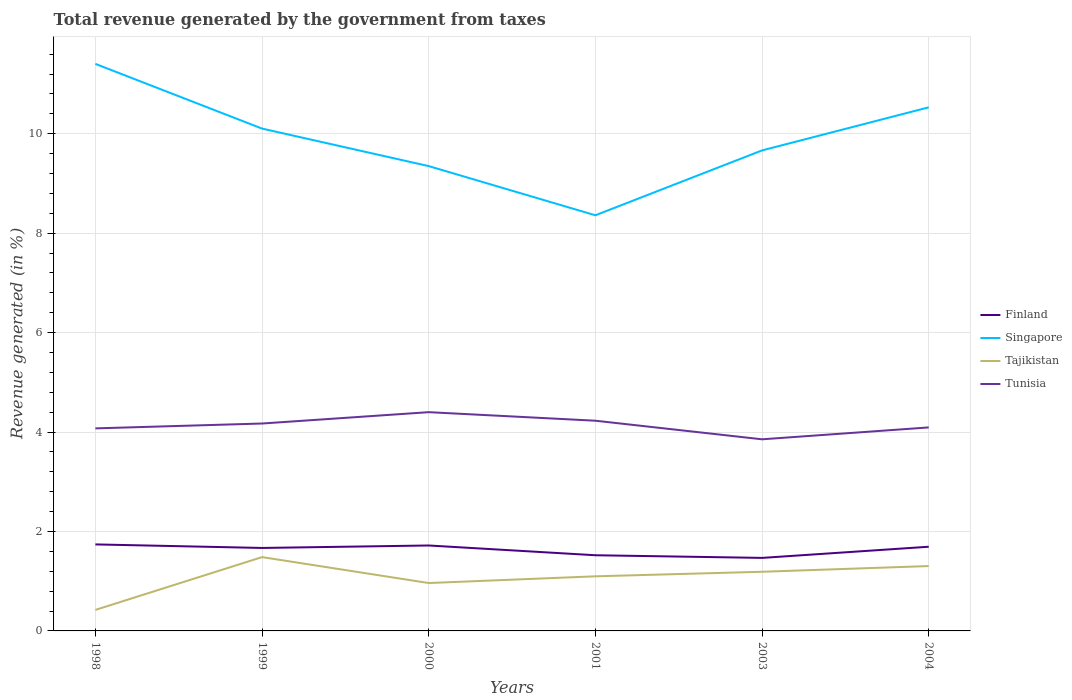How many different coloured lines are there?
Provide a short and direct response. 4. Is the number of lines equal to the number of legend labels?
Your response must be concise. Yes. Across all years, what is the maximum total revenue generated in Finland?
Make the answer very short. 1.47. What is the total total revenue generated in Tajikistan in the graph?
Keep it short and to the point. 0.18. What is the difference between the highest and the second highest total revenue generated in Tunisia?
Your response must be concise. 0.55. Is the total revenue generated in Finland strictly greater than the total revenue generated in Tunisia over the years?
Provide a succinct answer. Yes. How many lines are there?
Offer a terse response. 4. What is the difference between two consecutive major ticks on the Y-axis?
Ensure brevity in your answer.  2. Does the graph contain any zero values?
Keep it short and to the point. No. Does the graph contain grids?
Offer a very short reply. Yes. How many legend labels are there?
Give a very brief answer. 4. How are the legend labels stacked?
Your response must be concise. Vertical. What is the title of the graph?
Offer a terse response. Total revenue generated by the government from taxes. Does "Iran" appear as one of the legend labels in the graph?
Ensure brevity in your answer.  No. What is the label or title of the Y-axis?
Your answer should be compact. Revenue generated (in %). What is the Revenue generated (in %) in Finland in 1998?
Give a very brief answer. 1.74. What is the Revenue generated (in %) of Singapore in 1998?
Your answer should be compact. 11.41. What is the Revenue generated (in %) in Tajikistan in 1998?
Provide a short and direct response. 0.42. What is the Revenue generated (in %) in Tunisia in 1998?
Offer a very short reply. 4.07. What is the Revenue generated (in %) in Finland in 1999?
Make the answer very short. 1.67. What is the Revenue generated (in %) in Singapore in 1999?
Provide a succinct answer. 10.1. What is the Revenue generated (in %) of Tajikistan in 1999?
Your answer should be very brief. 1.48. What is the Revenue generated (in %) in Tunisia in 1999?
Your answer should be very brief. 4.17. What is the Revenue generated (in %) in Finland in 2000?
Offer a terse response. 1.72. What is the Revenue generated (in %) of Singapore in 2000?
Ensure brevity in your answer.  9.35. What is the Revenue generated (in %) in Tajikistan in 2000?
Your response must be concise. 0.96. What is the Revenue generated (in %) in Tunisia in 2000?
Your response must be concise. 4.4. What is the Revenue generated (in %) of Finland in 2001?
Your answer should be very brief. 1.52. What is the Revenue generated (in %) of Singapore in 2001?
Ensure brevity in your answer.  8.36. What is the Revenue generated (in %) in Tajikistan in 2001?
Your answer should be very brief. 1.1. What is the Revenue generated (in %) of Tunisia in 2001?
Offer a very short reply. 4.23. What is the Revenue generated (in %) of Finland in 2003?
Ensure brevity in your answer.  1.47. What is the Revenue generated (in %) in Singapore in 2003?
Provide a succinct answer. 9.67. What is the Revenue generated (in %) of Tajikistan in 2003?
Offer a terse response. 1.19. What is the Revenue generated (in %) of Tunisia in 2003?
Give a very brief answer. 3.85. What is the Revenue generated (in %) of Finland in 2004?
Provide a succinct answer. 1.69. What is the Revenue generated (in %) of Singapore in 2004?
Offer a terse response. 10.53. What is the Revenue generated (in %) in Tajikistan in 2004?
Your answer should be very brief. 1.3. What is the Revenue generated (in %) of Tunisia in 2004?
Your answer should be compact. 4.09. Across all years, what is the maximum Revenue generated (in %) of Finland?
Keep it short and to the point. 1.74. Across all years, what is the maximum Revenue generated (in %) in Singapore?
Make the answer very short. 11.41. Across all years, what is the maximum Revenue generated (in %) in Tajikistan?
Give a very brief answer. 1.48. Across all years, what is the maximum Revenue generated (in %) in Tunisia?
Your answer should be very brief. 4.4. Across all years, what is the minimum Revenue generated (in %) in Finland?
Offer a very short reply. 1.47. Across all years, what is the minimum Revenue generated (in %) of Singapore?
Your answer should be very brief. 8.36. Across all years, what is the minimum Revenue generated (in %) in Tajikistan?
Offer a terse response. 0.42. Across all years, what is the minimum Revenue generated (in %) of Tunisia?
Keep it short and to the point. 3.85. What is the total Revenue generated (in %) of Finland in the graph?
Your response must be concise. 9.81. What is the total Revenue generated (in %) of Singapore in the graph?
Offer a very short reply. 59.42. What is the total Revenue generated (in %) of Tajikistan in the graph?
Ensure brevity in your answer.  6.46. What is the total Revenue generated (in %) of Tunisia in the graph?
Your answer should be very brief. 24.82. What is the difference between the Revenue generated (in %) in Finland in 1998 and that in 1999?
Offer a very short reply. 0.07. What is the difference between the Revenue generated (in %) of Singapore in 1998 and that in 1999?
Offer a terse response. 1.3. What is the difference between the Revenue generated (in %) of Tajikistan in 1998 and that in 1999?
Provide a short and direct response. -1.06. What is the difference between the Revenue generated (in %) of Tunisia in 1998 and that in 1999?
Offer a terse response. -0.1. What is the difference between the Revenue generated (in %) in Finland in 1998 and that in 2000?
Give a very brief answer. 0.02. What is the difference between the Revenue generated (in %) in Singapore in 1998 and that in 2000?
Make the answer very short. 2.06. What is the difference between the Revenue generated (in %) in Tajikistan in 1998 and that in 2000?
Your response must be concise. -0.54. What is the difference between the Revenue generated (in %) in Tunisia in 1998 and that in 2000?
Offer a very short reply. -0.33. What is the difference between the Revenue generated (in %) in Finland in 1998 and that in 2001?
Your answer should be very brief. 0.22. What is the difference between the Revenue generated (in %) of Singapore in 1998 and that in 2001?
Provide a succinct answer. 3.05. What is the difference between the Revenue generated (in %) in Tajikistan in 1998 and that in 2001?
Provide a succinct answer. -0.68. What is the difference between the Revenue generated (in %) of Tunisia in 1998 and that in 2001?
Your answer should be very brief. -0.15. What is the difference between the Revenue generated (in %) in Finland in 1998 and that in 2003?
Offer a very short reply. 0.27. What is the difference between the Revenue generated (in %) of Singapore in 1998 and that in 2003?
Offer a terse response. 1.74. What is the difference between the Revenue generated (in %) in Tajikistan in 1998 and that in 2003?
Your response must be concise. -0.77. What is the difference between the Revenue generated (in %) in Tunisia in 1998 and that in 2003?
Keep it short and to the point. 0.22. What is the difference between the Revenue generated (in %) in Finland in 1998 and that in 2004?
Your response must be concise. 0.05. What is the difference between the Revenue generated (in %) of Singapore in 1998 and that in 2004?
Ensure brevity in your answer.  0.87. What is the difference between the Revenue generated (in %) of Tajikistan in 1998 and that in 2004?
Make the answer very short. -0.88. What is the difference between the Revenue generated (in %) in Tunisia in 1998 and that in 2004?
Offer a very short reply. -0.02. What is the difference between the Revenue generated (in %) in Finland in 1999 and that in 2000?
Your response must be concise. -0.05. What is the difference between the Revenue generated (in %) in Singapore in 1999 and that in 2000?
Offer a very short reply. 0.75. What is the difference between the Revenue generated (in %) of Tajikistan in 1999 and that in 2000?
Your answer should be very brief. 0.52. What is the difference between the Revenue generated (in %) of Tunisia in 1999 and that in 2000?
Give a very brief answer. -0.23. What is the difference between the Revenue generated (in %) in Finland in 1999 and that in 2001?
Make the answer very short. 0.15. What is the difference between the Revenue generated (in %) of Singapore in 1999 and that in 2001?
Your response must be concise. 1.74. What is the difference between the Revenue generated (in %) in Tajikistan in 1999 and that in 2001?
Provide a succinct answer. 0.39. What is the difference between the Revenue generated (in %) in Tunisia in 1999 and that in 2001?
Make the answer very short. -0.06. What is the difference between the Revenue generated (in %) in Finland in 1999 and that in 2003?
Provide a short and direct response. 0.2. What is the difference between the Revenue generated (in %) in Singapore in 1999 and that in 2003?
Offer a very short reply. 0.44. What is the difference between the Revenue generated (in %) of Tajikistan in 1999 and that in 2003?
Your answer should be compact. 0.29. What is the difference between the Revenue generated (in %) of Tunisia in 1999 and that in 2003?
Your response must be concise. 0.32. What is the difference between the Revenue generated (in %) in Finland in 1999 and that in 2004?
Make the answer very short. -0.02. What is the difference between the Revenue generated (in %) of Singapore in 1999 and that in 2004?
Provide a short and direct response. -0.43. What is the difference between the Revenue generated (in %) in Tajikistan in 1999 and that in 2004?
Keep it short and to the point. 0.18. What is the difference between the Revenue generated (in %) of Tunisia in 1999 and that in 2004?
Give a very brief answer. 0.08. What is the difference between the Revenue generated (in %) in Finland in 2000 and that in 2001?
Keep it short and to the point. 0.2. What is the difference between the Revenue generated (in %) of Tajikistan in 2000 and that in 2001?
Offer a very short reply. -0.14. What is the difference between the Revenue generated (in %) in Tunisia in 2000 and that in 2001?
Keep it short and to the point. 0.17. What is the difference between the Revenue generated (in %) of Finland in 2000 and that in 2003?
Provide a short and direct response. 0.25. What is the difference between the Revenue generated (in %) of Singapore in 2000 and that in 2003?
Keep it short and to the point. -0.32. What is the difference between the Revenue generated (in %) of Tajikistan in 2000 and that in 2003?
Ensure brevity in your answer.  -0.23. What is the difference between the Revenue generated (in %) in Tunisia in 2000 and that in 2003?
Give a very brief answer. 0.55. What is the difference between the Revenue generated (in %) of Finland in 2000 and that in 2004?
Your answer should be compact. 0.03. What is the difference between the Revenue generated (in %) of Singapore in 2000 and that in 2004?
Provide a succinct answer. -1.18. What is the difference between the Revenue generated (in %) in Tajikistan in 2000 and that in 2004?
Your answer should be compact. -0.34. What is the difference between the Revenue generated (in %) in Tunisia in 2000 and that in 2004?
Make the answer very short. 0.31. What is the difference between the Revenue generated (in %) of Finland in 2001 and that in 2003?
Keep it short and to the point. 0.05. What is the difference between the Revenue generated (in %) in Singapore in 2001 and that in 2003?
Ensure brevity in your answer.  -1.3. What is the difference between the Revenue generated (in %) in Tajikistan in 2001 and that in 2003?
Your answer should be very brief. -0.09. What is the difference between the Revenue generated (in %) in Tunisia in 2001 and that in 2003?
Ensure brevity in your answer.  0.37. What is the difference between the Revenue generated (in %) in Finland in 2001 and that in 2004?
Your answer should be very brief. -0.17. What is the difference between the Revenue generated (in %) in Singapore in 2001 and that in 2004?
Offer a terse response. -2.17. What is the difference between the Revenue generated (in %) of Tajikistan in 2001 and that in 2004?
Ensure brevity in your answer.  -0.21. What is the difference between the Revenue generated (in %) in Tunisia in 2001 and that in 2004?
Ensure brevity in your answer.  0.13. What is the difference between the Revenue generated (in %) of Finland in 2003 and that in 2004?
Offer a very short reply. -0.22. What is the difference between the Revenue generated (in %) of Singapore in 2003 and that in 2004?
Your answer should be very brief. -0.87. What is the difference between the Revenue generated (in %) of Tajikistan in 2003 and that in 2004?
Provide a succinct answer. -0.12. What is the difference between the Revenue generated (in %) in Tunisia in 2003 and that in 2004?
Ensure brevity in your answer.  -0.24. What is the difference between the Revenue generated (in %) in Finland in 1998 and the Revenue generated (in %) in Singapore in 1999?
Offer a very short reply. -8.36. What is the difference between the Revenue generated (in %) in Finland in 1998 and the Revenue generated (in %) in Tajikistan in 1999?
Your answer should be compact. 0.26. What is the difference between the Revenue generated (in %) in Finland in 1998 and the Revenue generated (in %) in Tunisia in 1999?
Your answer should be compact. -2.43. What is the difference between the Revenue generated (in %) in Singapore in 1998 and the Revenue generated (in %) in Tajikistan in 1999?
Make the answer very short. 9.92. What is the difference between the Revenue generated (in %) in Singapore in 1998 and the Revenue generated (in %) in Tunisia in 1999?
Your response must be concise. 7.23. What is the difference between the Revenue generated (in %) of Tajikistan in 1998 and the Revenue generated (in %) of Tunisia in 1999?
Offer a terse response. -3.75. What is the difference between the Revenue generated (in %) of Finland in 1998 and the Revenue generated (in %) of Singapore in 2000?
Your answer should be compact. -7.61. What is the difference between the Revenue generated (in %) of Finland in 1998 and the Revenue generated (in %) of Tajikistan in 2000?
Give a very brief answer. 0.78. What is the difference between the Revenue generated (in %) in Finland in 1998 and the Revenue generated (in %) in Tunisia in 2000?
Offer a very short reply. -2.66. What is the difference between the Revenue generated (in %) in Singapore in 1998 and the Revenue generated (in %) in Tajikistan in 2000?
Provide a short and direct response. 10.44. What is the difference between the Revenue generated (in %) of Singapore in 1998 and the Revenue generated (in %) of Tunisia in 2000?
Offer a very short reply. 7.01. What is the difference between the Revenue generated (in %) of Tajikistan in 1998 and the Revenue generated (in %) of Tunisia in 2000?
Offer a terse response. -3.98. What is the difference between the Revenue generated (in %) in Finland in 1998 and the Revenue generated (in %) in Singapore in 2001?
Keep it short and to the point. -6.62. What is the difference between the Revenue generated (in %) in Finland in 1998 and the Revenue generated (in %) in Tajikistan in 2001?
Offer a very short reply. 0.64. What is the difference between the Revenue generated (in %) of Finland in 1998 and the Revenue generated (in %) of Tunisia in 2001?
Offer a very short reply. -2.49. What is the difference between the Revenue generated (in %) of Singapore in 1998 and the Revenue generated (in %) of Tajikistan in 2001?
Offer a terse response. 10.31. What is the difference between the Revenue generated (in %) in Singapore in 1998 and the Revenue generated (in %) in Tunisia in 2001?
Your answer should be compact. 7.18. What is the difference between the Revenue generated (in %) of Tajikistan in 1998 and the Revenue generated (in %) of Tunisia in 2001?
Your answer should be compact. -3.81. What is the difference between the Revenue generated (in %) of Finland in 1998 and the Revenue generated (in %) of Singapore in 2003?
Offer a very short reply. -7.93. What is the difference between the Revenue generated (in %) of Finland in 1998 and the Revenue generated (in %) of Tajikistan in 2003?
Offer a very short reply. 0.55. What is the difference between the Revenue generated (in %) of Finland in 1998 and the Revenue generated (in %) of Tunisia in 2003?
Keep it short and to the point. -2.11. What is the difference between the Revenue generated (in %) of Singapore in 1998 and the Revenue generated (in %) of Tajikistan in 2003?
Your answer should be compact. 10.22. What is the difference between the Revenue generated (in %) in Singapore in 1998 and the Revenue generated (in %) in Tunisia in 2003?
Keep it short and to the point. 7.55. What is the difference between the Revenue generated (in %) of Tajikistan in 1998 and the Revenue generated (in %) of Tunisia in 2003?
Keep it short and to the point. -3.43. What is the difference between the Revenue generated (in %) of Finland in 1998 and the Revenue generated (in %) of Singapore in 2004?
Your answer should be compact. -8.79. What is the difference between the Revenue generated (in %) of Finland in 1998 and the Revenue generated (in %) of Tajikistan in 2004?
Make the answer very short. 0.44. What is the difference between the Revenue generated (in %) of Finland in 1998 and the Revenue generated (in %) of Tunisia in 2004?
Provide a short and direct response. -2.35. What is the difference between the Revenue generated (in %) of Singapore in 1998 and the Revenue generated (in %) of Tajikistan in 2004?
Make the answer very short. 10.1. What is the difference between the Revenue generated (in %) in Singapore in 1998 and the Revenue generated (in %) in Tunisia in 2004?
Your response must be concise. 7.31. What is the difference between the Revenue generated (in %) in Tajikistan in 1998 and the Revenue generated (in %) in Tunisia in 2004?
Make the answer very short. -3.67. What is the difference between the Revenue generated (in %) in Finland in 1999 and the Revenue generated (in %) in Singapore in 2000?
Offer a very short reply. -7.68. What is the difference between the Revenue generated (in %) in Finland in 1999 and the Revenue generated (in %) in Tajikistan in 2000?
Make the answer very short. 0.71. What is the difference between the Revenue generated (in %) of Finland in 1999 and the Revenue generated (in %) of Tunisia in 2000?
Offer a terse response. -2.73. What is the difference between the Revenue generated (in %) of Singapore in 1999 and the Revenue generated (in %) of Tajikistan in 2000?
Offer a terse response. 9.14. What is the difference between the Revenue generated (in %) in Singapore in 1999 and the Revenue generated (in %) in Tunisia in 2000?
Make the answer very short. 5.7. What is the difference between the Revenue generated (in %) in Tajikistan in 1999 and the Revenue generated (in %) in Tunisia in 2000?
Make the answer very short. -2.92. What is the difference between the Revenue generated (in %) of Finland in 1999 and the Revenue generated (in %) of Singapore in 2001?
Make the answer very short. -6.69. What is the difference between the Revenue generated (in %) in Finland in 1999 and the Revenue generated (in %) in Tajikistan in 2001?
Your response must be concise. 0.57. What is the difference between the Revenue generated (in %) of Finland in 1999 and the Revenue generated (in %) of Tunisia in 2001?
Provide a short and direct response. -2.56. What is the difference between the Revenue generated (in %) of Singapore in 1999 and the Revenue generated (in %) of Tajikistan in 2001?
Offer a terse response. 9.01. What is the difference between the Revenue generated (in %) in Singapore in 1999 and the Revenue generated (in %) in Tunisia in 2001?
Give a very brief answer. 5.88. What is the difference between the Revenue generated (in %) of Tajikistan in 1999 and the Revenue generated (in %) of Tunisia in 2001?
Your answer should be compact. -2.74. What is the difference between the Revenue generated (in %) in Finland in 1999 and the Revenue generated (in %) in Singapore in 2003?
Provide a short and direct response. -8. What is the difference between the Revenue generated (in %) in Finland in 1999 and the Revenue generated (in %) in Tajikistan in 2003?
Ensure brevity in your answer.  0.48. What is the difference between the Revenue generated (in %) of Finland in 1999 and the Revenue generated (in %) of Tunisia in 2003?
Give a very brief answer. -2.19. What is the difference between the Revenue generated (in %) in Singapore in 1999 and the Revenue generated (in %) in Tajikistan in 2003?
Ensure brevity in your answer.  8.91. What is the difference between the Revenue generated (in %) of Singapore in 1999 and the Revenue generated (in %) of Tunisia in 2003?
Give a very brief answer. 6.25. What is the difference between the Revenue generated (in %) in Tajikistan in 1999 and the Revenue generated (in %) in Tunisia in 2003?
Make the answer very short. -2.37. What is the difference between the Revenue generated (in %) of Finland in 1999 and the Revenue generated (in %) of Singapore in 2004?
Your answer should be compact. -8.86. What is the difference between the Revenue generated (in %) of Finland in 1999 and the Revenue generated (in %) of Tajikistan in 2004?
Your response must be concise. 0.36. What is the difference between the Revenue generated (in %) of Finland in 1999 and the Revenue generated (in %) of Tunisia in 2004?
Keep it short and to the point. -2.42. What is the difference between the Revenue generated (in %) in Singapore in 1999 and the Revenue generated (in %) in Tajikistan in 2004?
Your response must be concise. 8.8. What is the difference between the Revenue generated (in %) of Singapore in 1999 and the Revenue generated (in %) of Tunisia in 2004?
Offer a very short reply. 6.01. What is the difference between the Revenue generated (in %) of Tajikistan in 1999 and the Revenue generated (in %) of Tunisia in 2004?
Provide a short and direct response. -2.61. What is the difference between the Revenue generated (in %) of Finland in 2000 and the Revenue generated (in %) of Singapore in 2001?
Provide a succinct answer. -6.64. What is the difference between the Revenue generated (in %) in Finland in 2000 and the Revenue generated (in %) in Tajikistan in 2001?
Make the answer very short. 0.62. What is the difference between the Revenue generated (in %) of Finland in 2000 and the Revenue generated (in %) of Tunisia in 2001?
Keep it short and to the point. -2.51. What is the difference between the Revenue generated (in %) in Singapore in 2000 and the Revenue generated (in %) in Tajikistan in 2001?
Give a very brief answer. 8.25. What is the difference between the Revenue generated (in %) in Singapore in 2000 and the Revenue generated (in %) in Tunisia in 2001?
Give a very brief answer. 5.12. What is the difference between the Revenue generated (in %) of Tajikistan in 2000 and the Revenue generated (in %) of Tunisia in 2001?
Provide a succinct answer. -3.26. What is the difference between the Revenue generated (in %) in Finland in 2000 and the Revenue generated (in %) in Singapore in 2003?
Offer a terse response. -7.95. What is the difference between the Revenue generated (in %) in Finland in 2000 and the Revenue generated (in %) in Tajikistan in 2003?
Provide a short and direct response. 0.53. What is the difference between the Revenue generated (in %) of Finland in 2000 and the Revenue generated (in %) of Tunisia in 2003?
Make the answer very short. -2.14. What is the difference between the Revenue generated (in %) in Singapore in 2000 and the Revenue generated (in %) in Tajikistan in 2003?
Your answer should be compact. 8.16. What is the difference between the Revenue generated (in %) in Singapore in 2000 and the Revenue generated (in %) in Tunisia in 2003?
Your answer should be compact. 5.5. What is the difference between the Revenue generated (in %) of Tajikistan in 2000 and the Revenue generated (in %) of Tunisia in 2003?
Ensure brevity in your answer.  -2.89. What is the difference between the Revenue generated (in %) in Finland in 2000 and the Revenue generated (in %) in Singapore in 2004?
Your answer should be compact. -8.81. What is the difference between the Revenue generated (in %) of Finland in 2000 and the Revenue generated (in %) of Tajikistan in 2004?
Provide a succinct answer. 0.41. What is the difference between the Revenue generated (in %) of Finland in 2000 and the Revenue generated (in %) of Tunisia in 2004?
Give a very brief answer. -2.37. What is the difference between the Revenue generated (in %) in Singapore in 2000 and the Revenue generated (in %) in Tajikistan in 2004?
Offer a very short reply. 8.04. What is the difference between the Revenue generated (in %) of Singapore in 2000 and the Revenue generated (in %) of Tunisia in 2004?
Keep it short and to the point. 5.26. What is the difference between the Revenue generated (in %) in Tajikistan in 2000 and the Revenue generated (in %) in Tunisia in 2004?
Give a very brief answer. -3.13. What is the difference between the Revenue generated (in %) in Finland in 2001 and the Revenue generated (in %) in Singapore in 2003?
Give a very brief answer. -8.14. What is the difference between the Revenue generated (in %) in Finland in 2001 and the Revenue generated (in %) in Tajikistan in 2003?
Your response must be concise. 0.33. What is the difference between the Revenue generated (in %) of Finland in 2001 and the Revenue generated (in %) of Tunisia in 2003?
Your response must be concise. -2.33. What is the difference between the Revenue generated (in %) of Singapore in 2001 and the Revenue generated (in %) of Tajikistan in 2003?
Offer a very short reply. 7.17. What is the difference between the Revenue generated (in %) of Singapore in 2001 and the Revenue generated (in %) of Tunisia in 2003?
Give a very brief answer. 4.51. What is the difference between the Revenue generated (in %) in Tajikistan in 2001 and the Revenue generated (in %) in Tunisia in 2003?
Give a very brief answer. -2.76. What is the difference between the Revenue generated (in %) of Finland in 2001 and the Revenue generated (in %) of Singapore in 2004?
Keep it short and to the point. -9.01. What is the difference between the Revenue generated (in %) in Finland in 2001 and the Revenue generated (in %) in Tajikistan in 2004?
Your answer should be very brief. 0.22. What is the difference between the Revenue generated (in %) in Finland in 2001 and the Revenue generated (in %) in Tunisia in 2004?
Provide a succinct answer. -2.57. What is the difference between the Revenue generated (in %) in Singapore in 2001 and the Revenue generated (in %) in Tajikistan in 2004?
Your answer should be very brief. 7.06. What is the difference between the Revenue generated (in %) of Singapore in 2001 and the Revenue generated (in %) of Tunisia in 2004?
Your answer should be compact. 4.27. What is the difference between the Revenue generated (in %) of Tajikistan in 2001 and the Revenue generated (in %) of Tunisia in 2004?
Provide a short and direct response. -2.99. What is the difference between the Revenue generated (in %) in Finland in 2003 and the Revenue generated (in %) in Singapore in 2004?
Your answer should be very brief. -9.06. What is the difference between the Revenue generated (in %) of Finland in 2003 and the Revenue generated (in %) of Tajikistan in 2004?
Your answer should be compact. 0.16. What is the difference between the Revenue generated (in %) of Finland in 2003 and the Revenue generated (in %) of Tunisia in 2004?
Make the answer very short. -2.62. What is the difference between the Revenue generated (in %) of Singapore in 2003 and the Revenue generated (in %) of Tajikistan in 2004?
Keep it short and to the point. 8.36. What is the difference between the Revenue generated (in %) in Singapore in 2003 and the Revenue generated (in %) in Tunisia in 2004?
Provide a short and direct response. 5.57. What is the difference between the Revenue generated (in %) of Tajikistan in 2003 and the Revenue generated (in %) of Tunisia in 2004?
Your answer should be compact. -2.9. What is the average Revenue generated (in %) of Finland per year?
Offer a terse response. 1.64. What is the average Revenue generated (in %) of Singapore per year?
Provide a short and direct response. 9.9. What is the average Revenue generated (in %) of Tajikistan per year?
Give a very brief answer. 1.08. What is the average Revenue generated (in %) in Tunisia per year?
Make the answer very short. 4.14. In the year 1998, what is the difference between the Revenue generated (in %) of Finland and Revenue generated (in %) of Singapore?
Ensure brevity in your answer.  -9.67. In the year 1998, what is the difference between the Revenue generated (in %) in Finland and Revenue generated (in %) in Tajikistan?
Provide a succinct answer. 1.32. In the year 1998, what is the difference between the Revenue generated (in %) of Finland and Revenue generated (in %) of Tunisia?
Ensure brevity in your answer.  -2.33. In the year 1998, what is the difference between the Revenue generated (in %) in Singapore and Revenue generated (in %) in Tajikistan?
Offer a terse response. 10.98. In the year 1998, what is the difference between the Revenue generated (in %) in Singapore and Revenue generated (in %) in Tunisia?
Keep it short and to the point. 7.33. In the year 1998, what is the difference between the Revenue generated (in %) in Tajikistan and Revenue generated (in %) in Tunisia?
Provide a short and direct response. -3.65. In the year 1999, what is the difference between the Revenue generated (in %) of Finland and Revenue generated (in %) of Singapore?
Offer a terse response. -8.44. In the year 1999, what is the difference between the Revenue generated (in %) in Finland and Revenue generated (in %) in Tajikistan?
Your answer should be very brief. 0.18. In the year 1999, what is the difference between the Revenue generated (in %) in Finland and Revenue generated (in %) in Tunisia?
Your answer should be compact. -2.5. In the year 1999, what is the difference between the Revenue generated (in %) in Singapore and Revenue generated (in %) in Tajikistan?
Provide a short and direct response. 8.62. In the year 1999, what is the difference between the Revenue generated (in %) in Singapore and Revenue generated (in %) in Tunisia?
Give a very brief answer. 5.93. In the year 1999, what is the difference between the Revenue generated (in %) of Tajikistan and Revenue generated (in %) of Tunisia?
Provide a succinct answer. -2.69. In the year 2000, what is the difference between the Revenue generated (in %) in Finland and Revenue generated (in %) in Singapore?
Your answer should be very brief. -7.63. In the year 2000, what is the difference between the Revenue generated (in %) of Finland and Revenue generated (in %) of Tajikistan?
Ensure brevity in your answer.  0.76. In the year 2000, what is the difference between the Revenue generated (in %) of Finland and Revenue generated (in %) of Tunisia?
Ensure brevity in your answer.  -2.68. In the year 2000, what is the difference between the Revenue generated (in %) in Singapore and Revenue generated (in %) in Tajikistan?
Your answer should be compact. 8.39. In the year 2000, what is the difference between the Revenue generated (in %) of Singapore and Revenue generated (in %) of Tunisia?
Provide a short and direct response. 4.95. In the year 2000, what is the difference between the Revenue generated (in %) in Tajikistan and Revenue generated (in %) in Tunisia?
Give a very brief answer. -3.44. In the year 2001, what is the difference between the Revenue generated (in %) in Finland and Revenue generated (in %) in Singapore?
Provide a succinct answer. -6.84. In the year 2001, what is the difference between the Revenue generated (in %) of Finland and Revenue generated (in %) of Tajikistan?
Give a very brief answer. 0.42. In the year 2001, what is the difference between the Revenue generated (in %) of Finland and Revenue generated (in %) of Tunisia?
Your answer should be very brief. -2.71. In the year 2001, what is the difference between the Revenue generated (in %) in Singapore and Revenue generated (in %) in Tajikistan?
Make the answer very short. 7.26. In the year 2001, what is the difference between the Revenue generated (in %) in Singapore and Revenue generated (in %) in Tunisia?
Keep it short and to the point. 4.13. In the year 2001, what is the difference between the Revenue generated (in %) in Tajikistan and Revenue generated (in %) in Tunisia?
Give a very brief answer. -3.13. In the year 2003, what is the difference between the Revenue generated (in %) of Finland and Revenue generated (in %) of Singapore?
Provide a short and direct response. -8.2. In the year 2003, what is the difference between the Revenue generated (in %) of Finland and Revenue generated (in %) of Tajikistan?
Give a very brief answer. 0.28. In the year 2003, what is the difference between the Revenue generated (in %) in Finland and Revenue generated (in %) in Tunisia?
Provide a short and direct response. -2.39. In the year 2003, what is the difference between the Revenue generated (in %) of Singapore and Revenue generated (in %) of Tajikistan?
Your answer should be very brief. 8.48. In the year 2003, what is the difference between the Revenue generated (in %) of Singapore and Revenue generated (in %) of Tunisia?
Give a very brief answer. 5.81. In the year 2003, what is the difference between the Revenue generated (in %) in Tajikistan and Revenue generated (in %) in Tunisia?
Provide a succinct answer. -2.66. In the year 2004, what is the difference between the Revenue generated (in %) of Finland and Revenue generated (in %) of Singapore?
Provide a short and direct response. -8.84. In the year 2004, what is the difference between the Revenue generated (in %) of Finland and Revenue generated (in %) of Tajikistan?
Your answer should be very brief. 0.39. In the year 2004, what is the difference between the Revenue generated (in %) in Singapore and Revenue generated (in %) in Tajikistan?
Provide a short and direct response. 9.23. In the year 2004, what is the difference between the Revenue generated (in %) of Singapore and Revenue generated (in %) of Tunisia?
Your response must be concise. 6.44. In the year 2004, what is the difference between the Revenue generated (in %) in Tajikistan and Revenue generated (in %) in Tunisia?
Your response must be concise. -2.79. What is the ratio of the Revenue generated (in %) of Finland in 1998 to that in 1999?
Offer a terse response. 1.04. What is the ratio of the Revenue generated (in %) in Singapore in 1998 to that in 1999?
Your answer should be compact. 1.13. What is the ratio of the Revenue generated (in %) of Tajikistan in 1998 to that in 1999?
Your answer should be compact. 0.28. What is the ratio of the Revenue generated (in %) in Tunisia in 1998 to that in 1999?
Your response must be concise. 0.98. What is the ratio of the Revenue generated (in %) in Finland in 1998 to that in 2000?
Offer a terse response. 1.01. What is the ratio of the Revenue generated (in %) of Singapore in 1998 to that in 2000?
Provide a succinct answer. 1.22. What is the ratio of the Revenue generated (in %) of Tajikistan in 1998 to that in 2000?
Your answer should be very brief. 0.44. What is the ratio of the Revenue generated (in %) of Tunisia in 1998 to that in 2000?
Offer a terse response. 0.93. What is the ratio of the Revenue generated (in %) of Finland in 1998 to that in 2001?
Ensure brevity in your answer.  1.14. What is the ratio of the Revenue generated (in %) of Singapore in 1998 to that in 2001?
Keep it short and to the point. 1.36. What is the ratio of the Revenue generated (in %) in Tajikistan in 1998 to that in 2001?
Ensure brevity in your answer.  0.38. What is the ratio of the Revenue generated (in %) in Tunisia in 1998 to that in 2001?
Offer a very short reply. 0.96. What is the ratio of the Revenue generated (in %) in Finland in 1998 to that in 2003?
Your answer should be compact. 1.18. What is the ratio of the Revenue generated (in %) in Singapore in 1998 to that in 2003?
Provide a short and direct response. 1.18. What is the ratio of the Revenue generated (in %) in Tajikistan in 1998 to that in 2003?
Offer a terse response. 0.36. What is the ratio of the Revenue generated (in %) in Tunisia in 1998 to that in 2003?
Your answer should be very brief. 1.06. What is the ratio of the Revenue generated (in %) in Finland in 1998 to that in 2004?
Keep it short and to the point. 1.03. What is the ratio of the Revenue generated (in %) of Singapore in 1998 to that in 2004?
Your answer should be very brief. 1.08. What is the ratio of the Revenue generated (in %) of Tajikistan in 1998 to that in 2004?
Your response must be concise. 0.32. What is the ratio of the Revenue generated (in %) of Finland in 1999 to that in 2000?
Give a very brief answer. 0.97. What is the ratio of the Revenue generated (in %) in Singapore in 1999 to that in 2000?
Keep it short and to the point. 1.08. What is the ratio of the Revenue generated (in %) in Tajikistan in 1999 to that in 2000?
Your answer should be very brief. 1.54. What is the ratio of the Revenue generated (in %) in Tunisia in 1999 to that in 2000?
Ensure brevity in your answer.  0.95. What is the ratio of the Revenue generated (in %) of Finland in 1999 to that in 2001?
Your response must be concise. 1.1. What is the ratio of the Revenue generated (in %) in Singapore in 1999 to that in 2001?
Provide a short and direct response. 1.21. What is the ratio of the Revenue generated (in %) of Tajikistan in 1999 to that in 2001?
Provide a succinct answer. 1.35. What is the ratio of the Revenue generated (in %) in Tunisia in 1999 to that in 2001?
Offer a very short reply. 0.99. What is the ratio of the Revenue generated (in %) of Finland in 1999 to that in 2003?
Provide a short and direct response. 1.14. What is the ratio of the Revenue generated (in %) in Singapore in 1999 to that in 2003?
Provide a short and direct response. 1.05. What is the ratio of the Revenue generated (in %) of Tajikistan in 1999 to that in 2003?
Provide a succinct answer. 1.25. What is the ratio of the Revenue generated (in %) in Tunisia in 1999 to that in 2003?
Give a very brief answer. 1.08. What is the ratio of the Revenue generated (in %) in Finland in 1999 to that in 2004?
Make the answer very short. 0.99. What is the ratio of the Revenue generated (in %) in Singapore in 1999 to that in 2004?
Your answer should be very brief. 0.96. What is the ratio of the Revenue generated (in %) of Tajikistan in 1999 to that in 2004?
Your answer should be very brief. 1.14. What is the ratio of the Revenue generated (in %) of Tunisia in 1999 to that in 2004?
Your response must be concise. 1.02. What is the ratio of the Revenue generated (in %) in Finland in 2000 to that in 2001?
Give a very brief answer. 1.13. What is the ratio of the Revenue generated (in %) of Singapore in 2000 to that in 2001?
Provide a succinct answer. 1.12. What is the ratio of the Revenue generated (in %) of Tajikistan in 2000 to that in 2001?
Offer a very short reply. 0.88. What is the ratio of the Revenue generated (in %) in Tunisia in 2000 to that in 2001?
Offer a very short reply. 1.04. What is the ratio of the Revenue generated (in %) in Finland in 2000 to that in 2003?
Provide a short and direct response. 1.17. What is the ratio of the Revenue generated (in %) in Singapore in 2000 to that in 2003?
Make the answer very short. 0.97. What is the ratio of the Revenue generated (in %) of Tajikistan in 2000 to that in 2003?
Provide a succinct answer. 0.81. What is the ratio of the Revenue generated (in %) in Tunisia in 2000 to that in 2003?
Keep it short and to the point. 1.14. What is the ratio of the Revenue generated (in %) of Finland in 2000 to that in 2004?
Keep it short and to the point. 1.01. What is the ratio of the Revenue generated (in %) of Singapore in 2000 to that in 2004?
Keep it short and to the point. 0.89. What is the ratio of the Revenue generated (in %) of Tajikistan in 2000 to that in 2004?
Keep it short and to the point. 0.74. What is the ratio of the Revenue generated (in %) of Tunisia in 2000 to that in 2004?
Your answer should be very brief. 1.07. What is the ratio of the Revenue generated (in %) of Finland in 2001 to that in 2003?
Ensure brevity in your answer.  1.04. What is the ratio of the Revenue generated (in %) in Singapore in 2001 to that in 2003?
Your answer should be very brief. 0.86. What is the ratio of the Revenue generated (in %) in Tajikistan in 2001 to that in 2003?
Your response must be concise. 0.92. What is the ratio of the Revenue generated (in %) of Tunisia in 2001 to that in 2003?
Offer a terse response. 1.1. What is the ratio of the Revenue generated (in %) of Finland in 2001 to that in 2004?
Your answer should be compact. 0.9. What is the ratio of the Revenue generated (in %) of Singapore in 2001 to that in 2004?
Your response must be concise. 0.79. What is the ratio of the Revenue generated (in %) in Tajikistan in 2001 to that in 2004?
Your answer should be very brief. 0.84. What is the ratio of the Revenue generated (in %) of Tunisia in 2001 to that in 2004?
Ensure brevity in your answer.  1.03. What is the ratio of the Revenue generated (in %) in Finland in 2003 to that in 2004?
Offer a terse response. 0.87. What is the ratio of the Revenue generated (in %) in Singapore in 2003 to that in 2004?
Make the answer very short. 0.92. What is the ratio of the Revenue generated (in %) in Tajikistan in 2003 to that in 2004?
Keep it short and to the point. 0.91. What is the ratio of the Revenue generated (in %) in Tunisia in 2003 to that in 2004?
Give a very brief answer. 0.94. What is the difference between the highest and the second highest Revenue generated (in %) of Finland?
Offer a very short reply. 0.02. What is the difference between the highest and the second highest Revenue generated (in %) in Singapore?
Offer a very short reply. 0.87. What is the difference between the highest and the second highest Revenue generated (in %) of Tajikistan?
Ensure brevity in your answer.  0.18. What is the difference between the highest and the second highest Revenue generated (in %) of Tunisia?
Offer a terse response. 0.17. What is the difference between the highest and the lowest Revenue generated (in %) of Finland?
Make the answer very short. 0.27. What is the difference between the highest and the lowest Revenue generated (in %) of Singapore?
Offer a very short reply. 3.05. What is the difference between the highest and the lowest Revenue generated (in %) in Tajikistan?
Provide a short and direct response. 1.06. What is the difference between the highest and the lowest Revenue generated (in %) of Tunisia?
Your response must be concise. 0.55. 